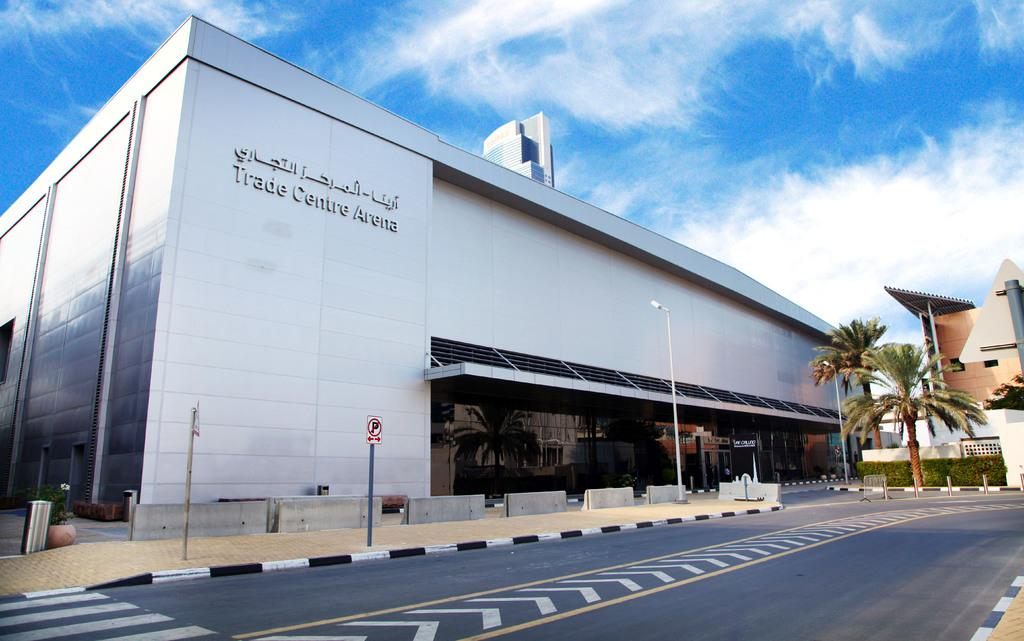What type of structures can be seen in the image? There are buildings in the image. What other natural elements are present in the image? There are trees in the image. What is located at the bottom of the image? There is a road at the bottom of the image. What are the vertical structures visible in the image? There are poles visible in the image. What type of informational display is present in the image? There is a sign board in the image. Where is the bin located in the image? The bin is on the left side of the image. What can be seen in the background of the image? The sky is visible in the background of the image. What color is the silver pocket in the image? There is no silver pocket present in the image. How does the act of walking affect the buildings in the image? The image does not depict any people walking, so the act of walking does not affect the buildings in the image. 